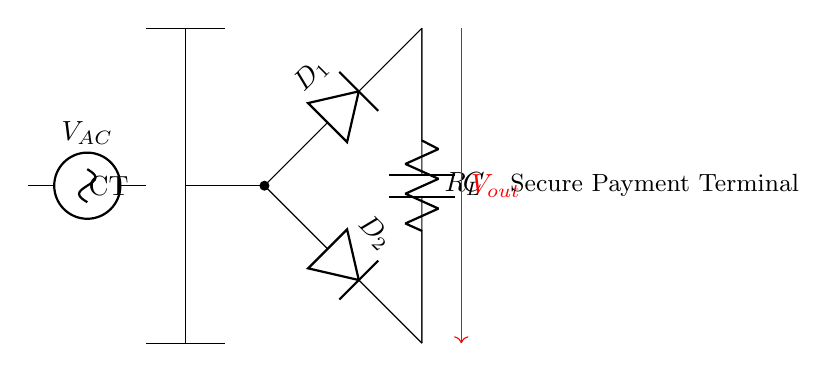What is the type of transformer used in this circuit? The circuit uses a center-tapped transformer, which is indicated by the labeling "CT" on the diagram. The presence of two output connections from the transformer confirms this type.
Answer: Center-tapped What are the components present in the circuit? The circuit includes a transformer, two diodes, a load resistor, and a capacitor. Each component is represented by a specific symbol in the diagram and labeled accordingly.
Answer: Transformer, diodes, resistor, capacitor What is the purpose of the diodes in this circuit? The diodes are used to convert AC voltage into DC voltage, allowing current to flow in one direction only. In this circuit, diode D1 allows current during one half of the AC cycle, while diode D2 allows current during the other half.
Answer: Rectification What is the output voltage of this rectifier circuit referred to in the diagram? The output voltage is denoted as "Vout" in the circuit, indicated by the red arrow showing the direction of the output voltage flow from the load.
Answer: Vout How many diodes are used in this configuration? The diagram shows two diodes labeled as D1 and D2, which are essential for enabling the rectification process in this center-tapped transformer setup.
Answer: Two What does the capacitor in the circuit do? The capacitor smooths out the fluctuating output voltage by charging during peaks and discharging during dips, thereby providing a more constant DC voltage to the load. This function is crucial for stable power supply in secure payment terminals.
Answer: Smoothing Why is a center-tapped transformer preferred for this application? A center-tapped transformer provides two separate output voltages from the transformer, allowing for efficient full-wave rectification. This leads to better voltage utilization and smoother DC output, which is vital for secure electronic payment terminals that require stable operation.
Answer: Efficient rectification 